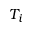<formula> <loc_0><loc_0><loc_500><loc_500>T _ { i }</formula> 